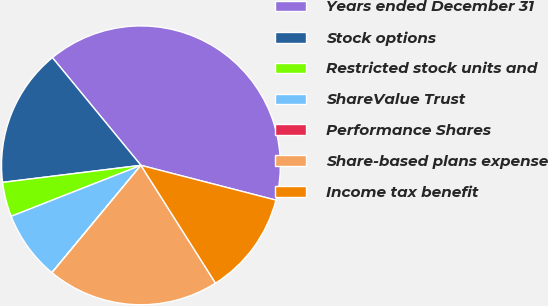<chart> <loc_0><loc_0><loc_500><loc_500><pie_chart><fcel>Years ended December 31<fcel>Stock options<fcel>Restricted stock units and<fcel>ShareValue Trust<fcel>Performance Shares<fcel>Share-based plans expense<fcel>Income tax benefit<nl><fcel>39.96%<fcel>16.0%<fcel>4.01%<fcel>8.01%<fcel>0.02%<fcel>19.99%<fcel>12.0%<nl></chart> 